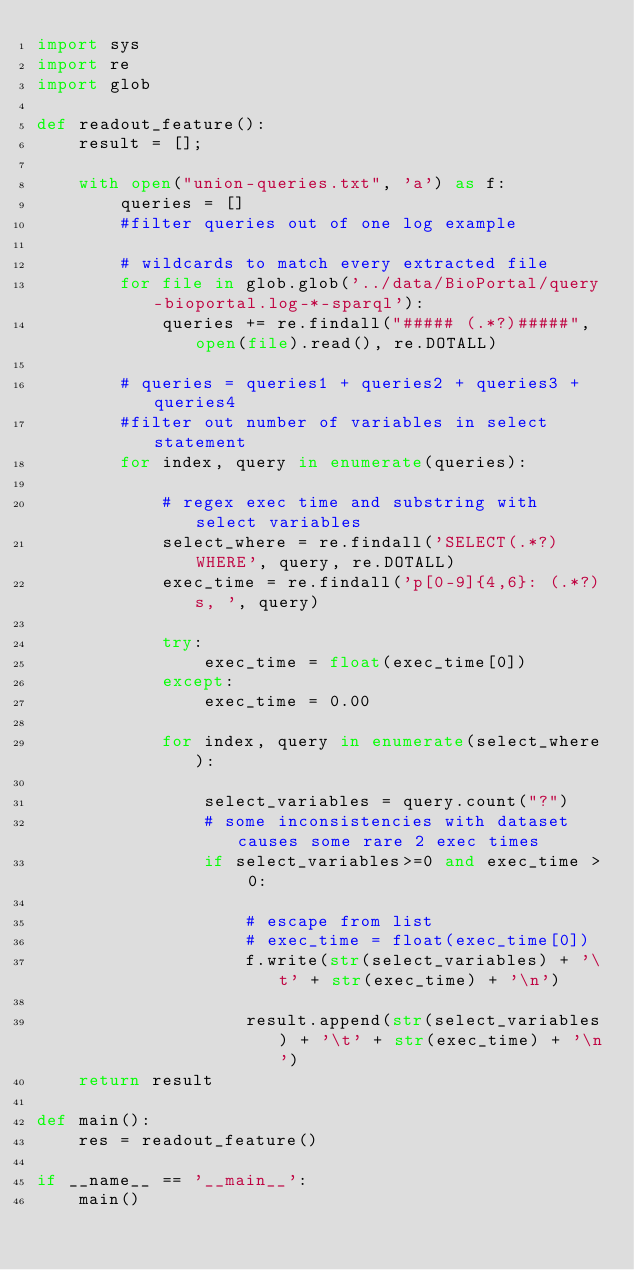Convert code to text. <code><loc_0><loc_0><loc_500><loc_500><_Python_>import sys
import re
import glob

def readout_feature():
	result = [];

	with open("union-queries.txt", 'a') as f:
		queries = []
		#filter queries out of one log example

		# wildcards to match every extracted file
		for file in glob.glob('../data/BioPortal/query-bioportal.log-*-sparql'):
			queries += re.findall("##### (.*?)#####", open(file).read(), re.DOTALL)

		# queries = queries1 + queries2 + queries3 + queries4
		#filter out number of variables in select statement
		for index, query in enumerate(queries):
			
			# regex exec time and substring with select variables
			select_where = re.findall('SELECT(.*?)WHERE', query, re.DOTALL)		
			exec_time = re.findall('p[0-9]{4,6}: (.*?)s, ', query)
			
			try:
				exec_time = float(exec_time[0])
			except:
				exec_time = 0.00

			for index, query in enumerate(select_where):
				
				select_variables = query.count("?")
				# some inconsistencies with dataset causes some rare 2 exec times 
				if select_variables>=0 and exec_time > 0:

					# escape from list
					# exec_time = float(exec_time[0])
					f.write(str(select_variables) + '\t' + str(exec_time) + '\n')

					result.append(str(select_variables) + '\t' + str(exec_time) + '\n')
	return result

def main():
	res = readout_feature()

if __name__ == '__main__':
	main()</code> 